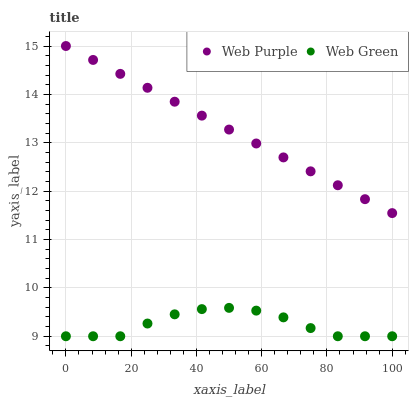Does Web Green have the minimum area under the curve?
Answer yes or no. Yes. Does Web Purple have the maximum area under the curve?
Answer yes or no. Yes. Does Web Green have the maximum area under the curve?
Answer yes or no. No. Is Web Purple the smoothest?
Answer yes or no. Yes. Is Web Green the roughest?
Answer yes or no. Yes. Is Web Green the smoothest?
Answer yes or no. No. Does Web Green have the lowest value?
Answer yes or no. Yes. Does Web Purple have the highest value?
Answer yes or no. Yes. Does Web Green have the highest value?
Answer yes or no. No. Is Web Green less than Web Purple?
Answer yes or no. Yes. Is Web Purple greater than Web Green?
Answer yes or no. Yes. Does Web Green intersect Web Purple?
Answer yes or no. No. 